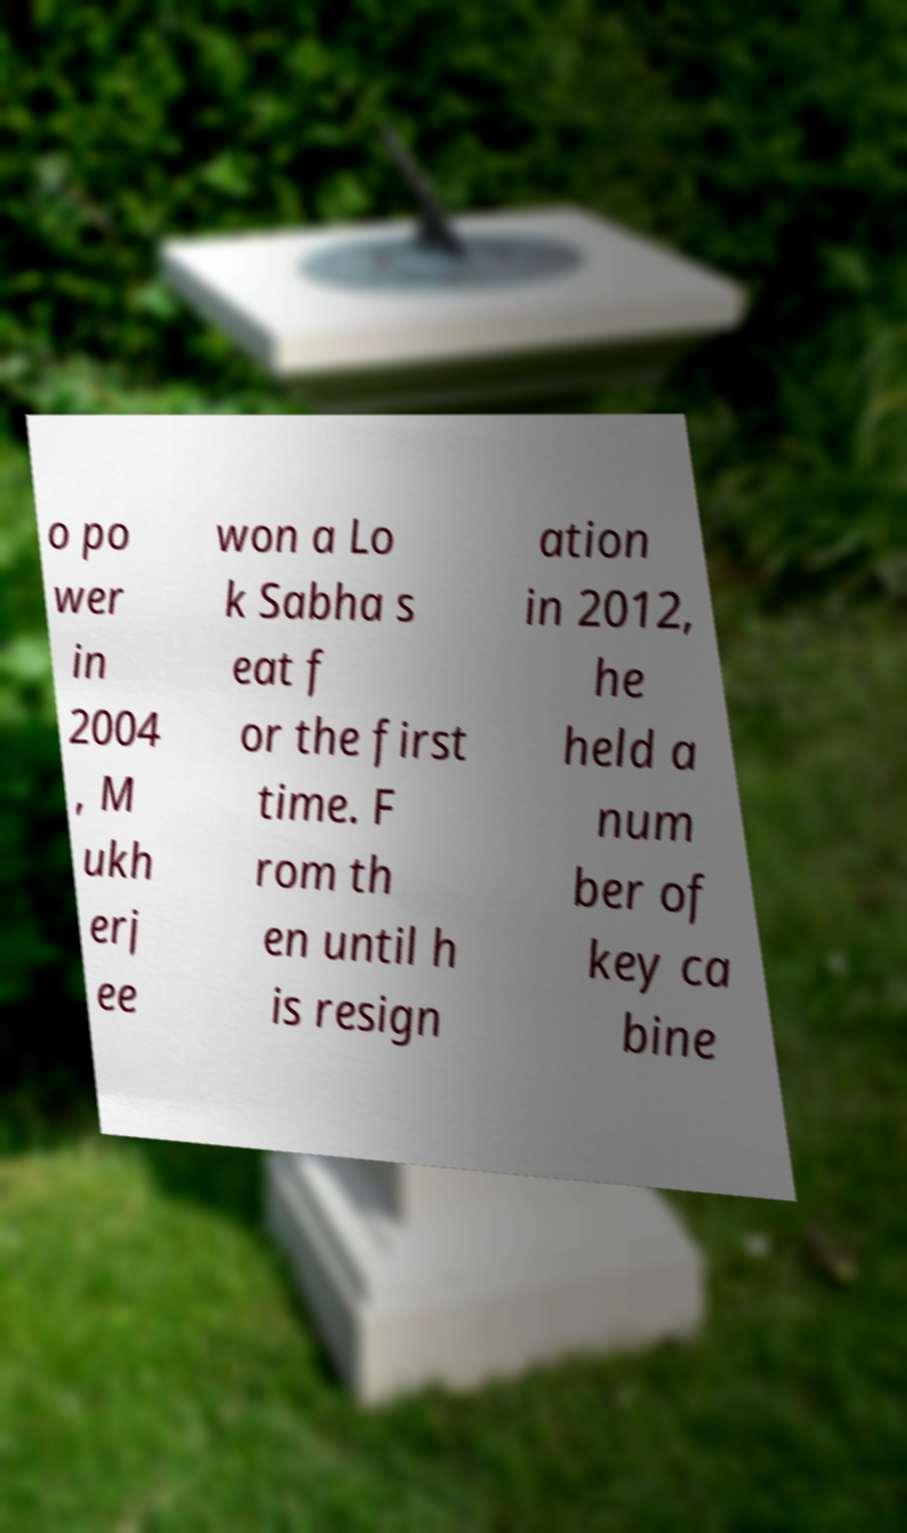Please identify and transcribe the text found in this image. o po wer in 2004 , M ukh erj ee won a Lo k Sabha s eat f or the first time. F rom th en until h is resign ation in 2012, he held a num ber of key ca bine 